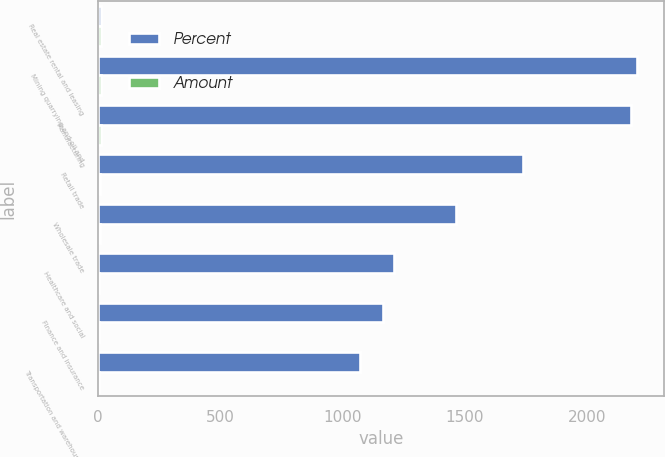Convert chart to OTSL. <chart><loc_0><loc_0><loc_500><loc_500><stacked_bar_chart><ecel><fcel>Real estate rental and leasing<fcel>Mining quarrying and oil and<fcel>Manufacturing<fcel>Retail trade<fcel>Wholesale trade<fcel>Healthcare and social<fcel>Finance and insurance<fcel>Transportation and warehousing<nl><fcel>Percent<fcel>14.1<fcel>2205<fcel>2181<fcel>1737<fcel>1464<fcel>1211<fcel>1168<fcel>1074<nl><fcel>Amount<fcel>14.1<fcel>10.6<fcel>10.5<fcel>8.4<fcel>7.1<fcel>5.8<fcel>5.6<fcel>5.2<nl></chart> 